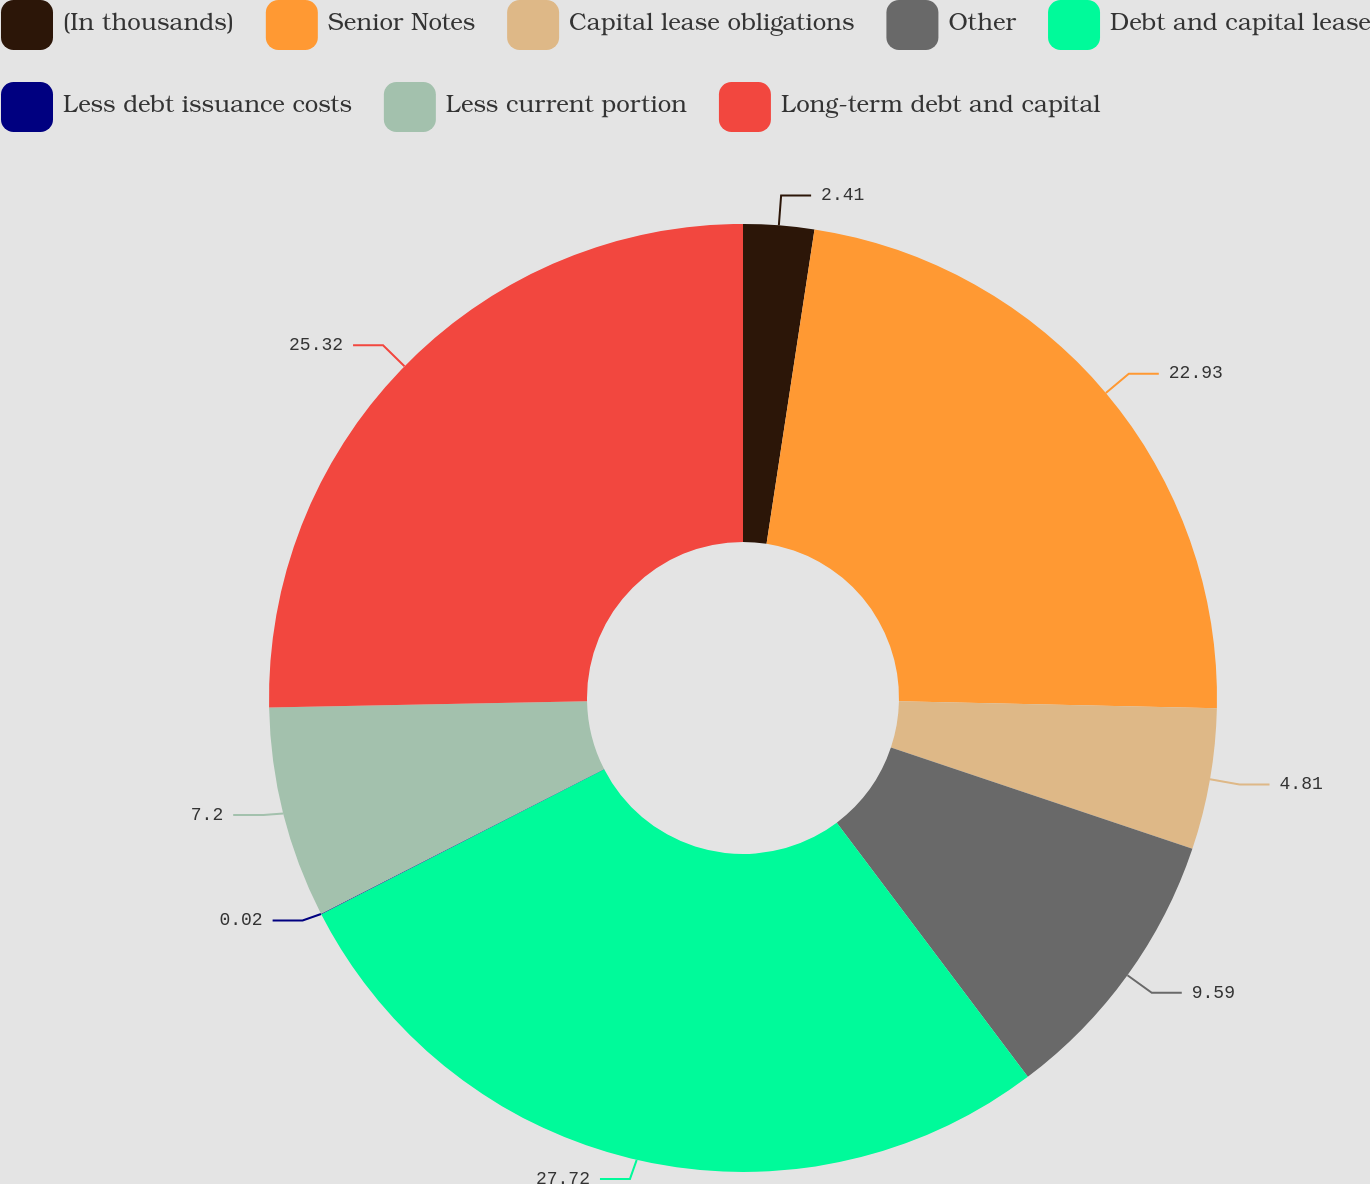Convert chart to OTSL. <chart><loc_0><loc_0><loc_500><loc_500><pie_chart><fcel>(In thousands)<fcel>Senior Notes<fcel>Capital lease obligations<fcel>Other<fcel>Debt and capital lease<fcel>Less debt issuance costs<fcel>Less current portion<fcel>Long-term debt and capital<nl><fcel>2.41%<fcel>22.93%<fcel>4.81%<fcel>9.59%<fcel>27.72%<fcel>0.02%<fcel>7.2%<fcel>25.32%<nl></chart> 